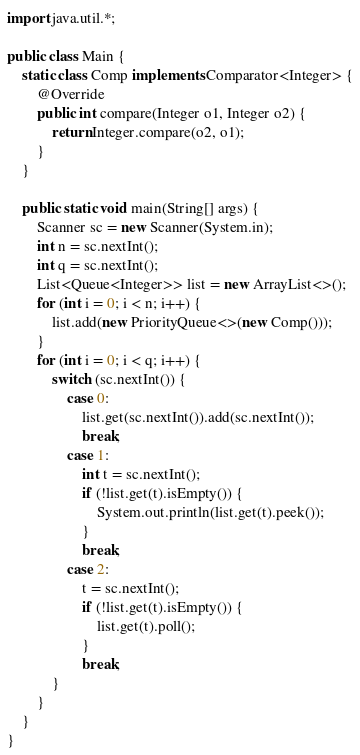<code> <loc_0><loc_0><loc_500><loc_500><_Java_>import java.util.*;

public class Main {
	static class Comp implements Comparator<Integer> {
		@Override
		public int compare(Integer o1, Integer o2) {
			return Integer.compare(o2, o1);
		}
	}
	
	public static void main(String[] args) {
		Scanner sc = new Scanner(System.in);
		int n = sc.nextInt();
		int q = sc.nextInt();
		List<Queue<Integer>> list = new ArrayList<>();
		for (int i = 0; i < n; i++) {
			list.add(new PriorityQueue<>(new Comp()));
		}
		for (int i = 0; i < q; i++) {
			switch (sc.nextInt()) {
				case 0:
					list.get(sc.nextInt()).add(sc.nextInt());
					break;
				case 1:
					int t = sc.nextInt();
					if (!list.get(t).isEmpty()) {
						System.out.println(list.get(t).peek());
					}
					break;
				case 2:
					t = sc.nextInt();
					if (!list.get(t).isEmpty()) {
						list.get(t).poll();
					}
					break;
			}
		}
	}
}
</code> 